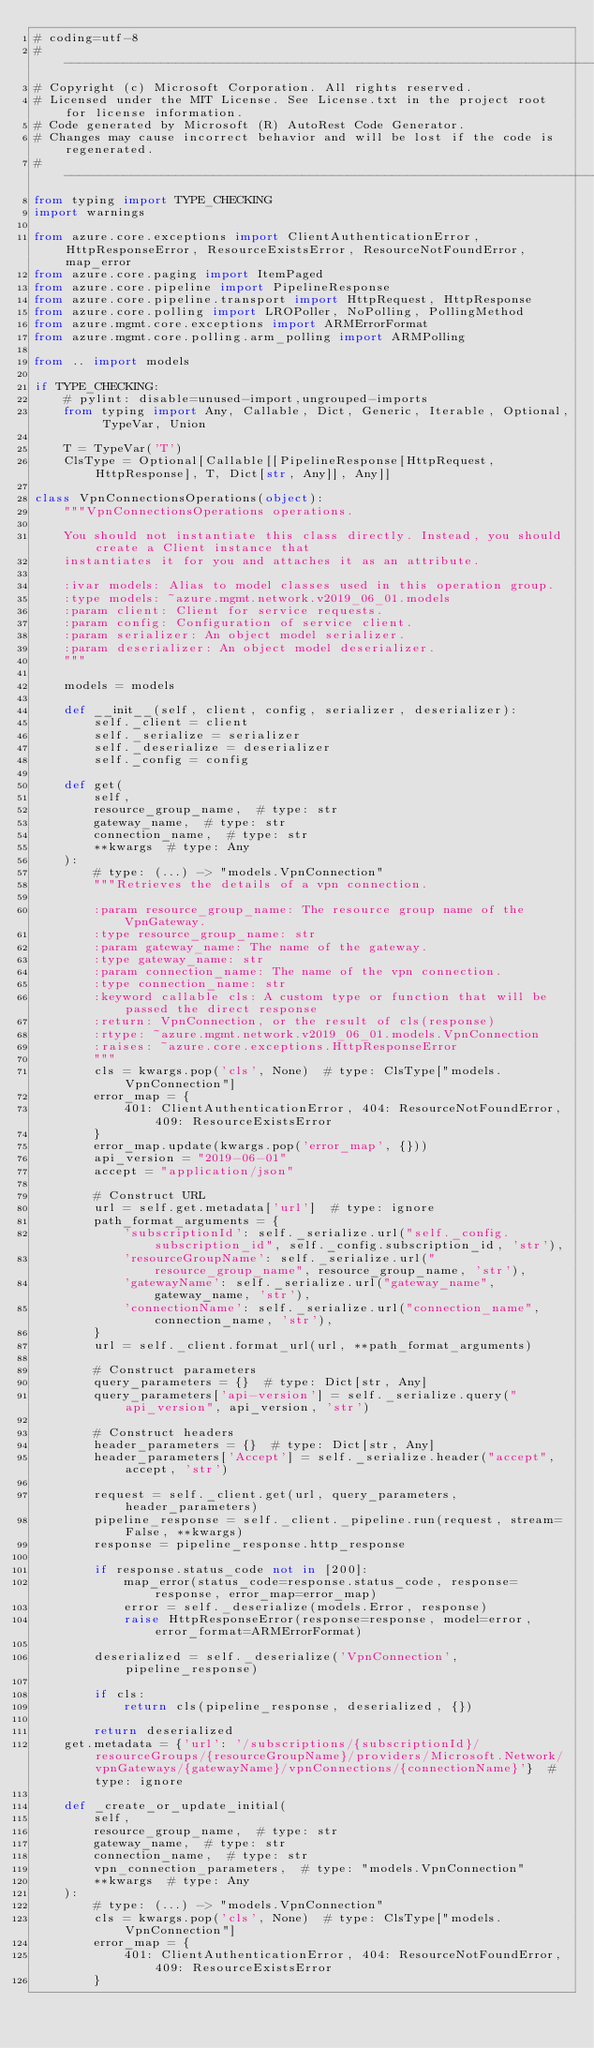<code> <loc_0><loc_0><loc_500><loc_500><_Python_># coding=utf-8
# --------------------------------------------------------------------------
# Copyright (c) Microsoft Corporation. All rights reserved.
# Licensed under the MIT License. See License.txt in the project root for license information.
# Code generated by Microsoft (R) AutoRest Code Generator.
# Changes may cause incorrect behavior and will be lost if the code is regenerated.
# --------------------------------------------------------------------------
from typing import TYPE_CHECKING
import warnings

from azure.core.exceptions import ClientAuthenticationError, HttpResponseError, ResourceExistsError, ResourceNotFoundError, map_error
from azure.core.paging import ItemPaged
from azure.core.pipeline import PipelineResponse
from azure.core.pipeline.transport import HttpRequest, HttpResponse
from azure.core.polling import LROPoller, NoPolling, PollingMethod
from azure.mgmt.core.exceptions import ARMErrorFormat
from azure.mgmt.core.polling.arm_polling import ARMPolling

from .. import models

if TYPE_CHECKING:
    # pylint: disable=unused-import,ungrouped-imports
    from typing import Any, Callable, Dict, Generic, Iterable, Optional, TypeVar, Union

    T = TypeVar('T')
    ClsType = Optional[Callable[[PipelineResponse[HttpRequest, HttpResponse], T, Dict[str, Any]], Any]]

class VpnConnectionsOperations(object):
    """VpnConnectionsOperations operations.

    You should not instantiate this class directly. Instead, you should create a Client instance that
    instantiates it for you and attaches it as an attribute.

    :ivar models: Alias to model classes used in this operation group.
    :type models: ~azure.mgmt.network.v2019_06_01.models
    :param client: Client for service requests.
    :param config: Configuration of service client.
    :param serializer: An object model serializer.
    :param deserializer: An object model deserializer.
    """

    models = models

    def __init__(self, client, config, serializer, deserializer):
        self._client = client
        self._serialize = serializer
        self._deserialize = deserializer
        self._config = config

    def get(
        self,
        resource_group_name,  # type: str
        gateway_name,  # type: str
        connection_name,  # type: str
        **kwargs  # type: Any
    ):
        # type: (...) -> "models.VpnConnection"
        """Retrieves the details of a vpn connection.

        :param resource_group_name: The resource group name of the VpnGateway.
        :type resource_group_name: str
        :param gateway_name: The name of the gateway.
        :type gateway_name: str
        :param connection_name: The name of the vpn connection.
        :type connection_name: str
        :keyword callable cls: A custom type or function that will be passed the direct response
        :return: VpnConnection, or the result of cls(response)
        :rtype: ~azure.mgmt.network.v2019_06_01.models.VpnConnection
        :raises: ~azure.core.exceptions.HttpResponseError
        """
        cls = kwargs.pop('cls', None)  # type: ClsType["models.VpnConnection"]
        error_map = {
            401: ClientAuthenticationError, 404: ResourceNotFoundError, 409: ResourceExistsError
        }
        error_map.update(kwargs.pop('error_map', {}))
        api_version = "2019-06-01"
        accept = "application/json"

        # Construct URL
        url = self.get.metadata['url']  # type: ignore
        path_format_arguments = {
            'subscriptionId': self._serialize.url("self._config.subscription_id", self._config.subscription_id, 'str'),
            'resourceGroupName': self._serialize.url("resource_group_name", resource_group_name, 'str'),
            'gatewayName': self._serialize.url("gateway_name", gateway_name, 'str'),
            'connectionName': self._serialize.url("connection_name", connection_name, 'str'),
        }
        url = self._client.format_url(url, **path_format_arguments)

        # Construct parameters
        query_parameters = {}  # type: Dict[str, Any]
        query_parameters['api-version'] = self._serialize.query("api_version", api_version, 'str')

        # Construct headers
        header_parameters = {}  # type: Dict[str, Any]
        header_parameters['Accept'] = self._serialize.header("accept", accept, 'str')

        request = self._client.get(url, query_parameters, header_parameters)
        pipeline_response = self._client._pipeline.run(request, stream=False, **kwargs)
        response = pipeline_response.http_response

        if response.status_code not in [200]:
            map_error(status_code=response.status_code, response=response, error_map=error_map)
            error = self._deserialize(models.Error, response)
            raise HttpResponseError(response=response, model=error, error_format=ARMErrorFormat)

        deserialized = self._deserialize('VpnConnection', pipeline_response)

        if cls:
            return cls(pipeline_response, deserialized, {})

        return deserialized
    get.metadata = {'url': '/subscriptions/{subscriptionId}/resourceGroups/{resourceGroupName}/providers/Microsoft.Network/vpnGateways/{gatewayName}/vpnConnections/{connectionName}'}  # type: ignore

    def _create_or_update_initial(
        self,
        resource_group_name,  # type: str
        gateway_name,  # type: str
        connection_name,  # type: str
        vpn_connection_parameters,  # type: "models.VpnConnection"
        **kwargs  # type: Any
    ):
        # type: (...) -> "models.VpnConnection"
        cls = kwargs.pop('cls', None)  # type: ClsType["models.VpnConnection"]
        error_map = {
            401: ClientAuthenticationError, 404: ResourceNotFoundError, 409: ResourceExistsError
        }</code> 